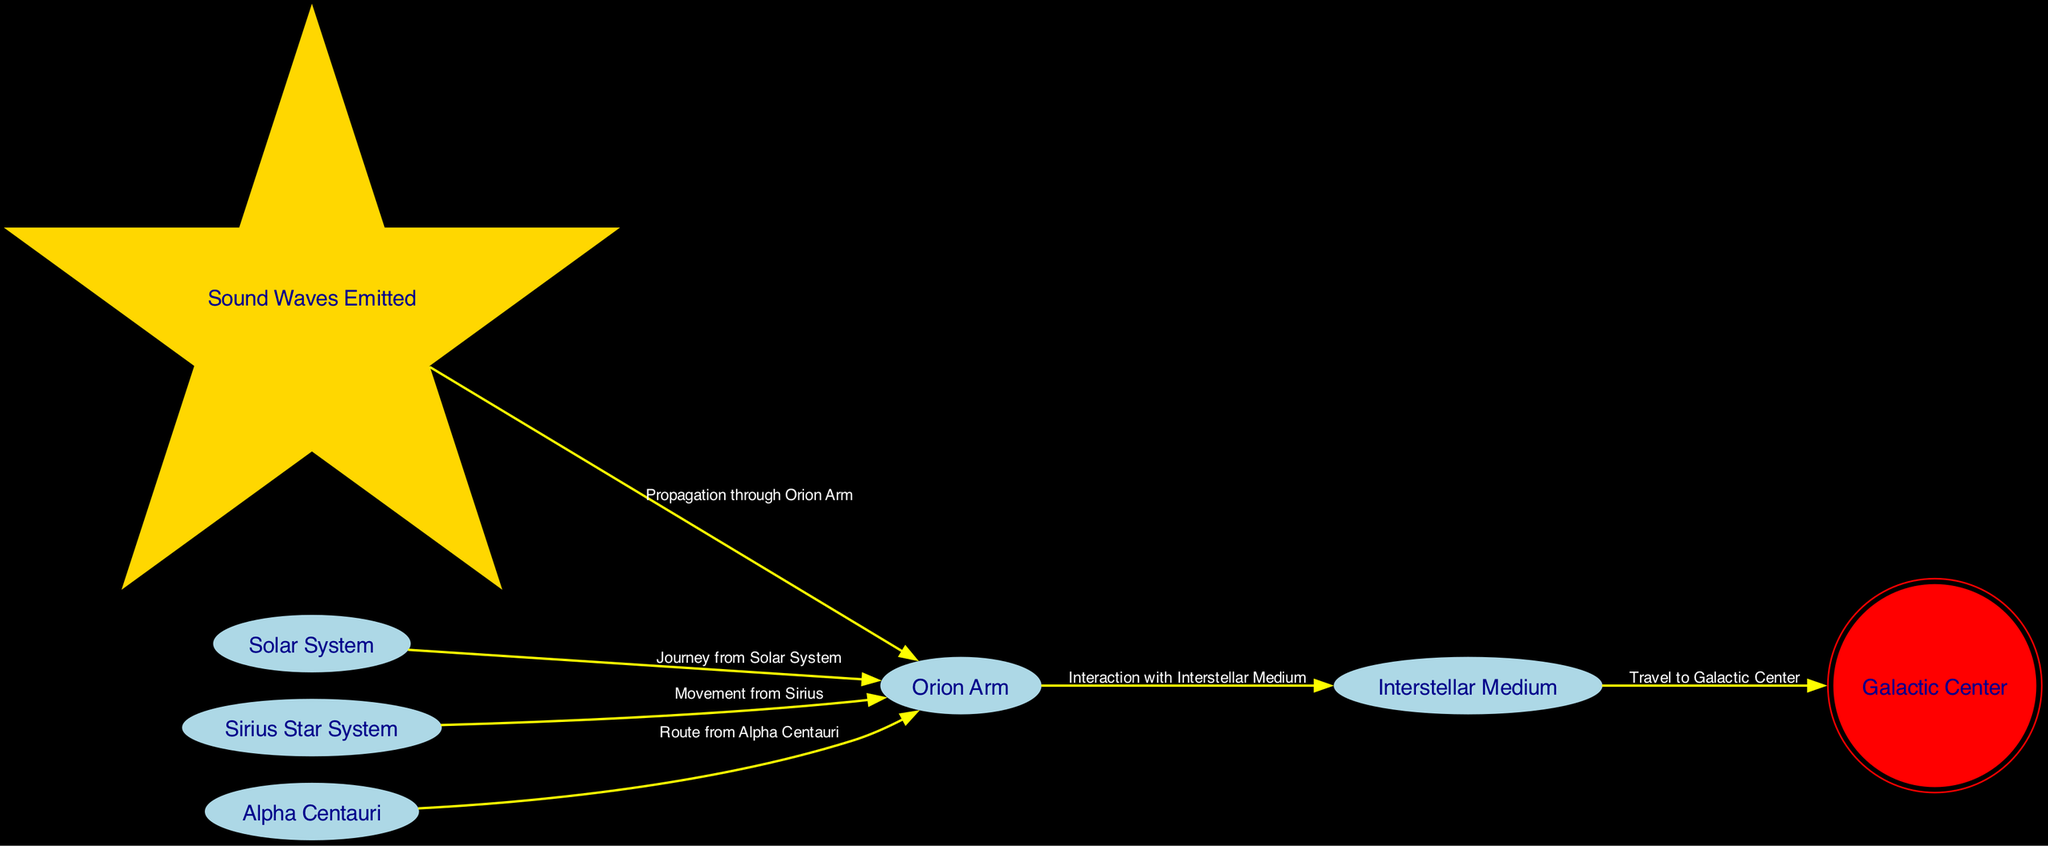What's the total number of nodes in the diagram? The diagram lists nodes that represent different locations or concepts related to sound waves in the Milky Way. Counting each entry, we find 7 distinct nodes total.
Answer: 7 What is the relationship between "Sound Waves Emitted" and "Orion Arm"? The diagram shows a direct edge labeled "Propagation through Orion Arm," indicating that sound waves emitted travel to this region. Therefore, there is a propagation relationship between these two nodes.
Answer: Propagation through Orion Arm How many edges are there in the diagram? By reviewing the connections displayed between the nodes, we can tally that there are 6 edges representing the different pathways and interactions.
Answer: 6 Which node represents the location of the Galactic Center? The node labeled "Galactic Center" is specifically identified in the diagram, making it easy to locate. The identification of the node is clear as it holds the label.
Answer: Galactic Center What are the two star systems shown in the diagram? The diagram features two star systems: "Sirius Star System" and "Alpha Centauri." These nodes are explicitly mentioned in the provided data.
Answer: Sirius Star System and Alpha Centauri From which location does sound have a journey to the "Orion Arm"? The "Solar System" node has a directed edge labeled "Journey from Solar System" leading towards the "Orion Arm," indicating that sound originates from here towards that arm.
Answer: Solar System What is the pathway from "Interstellar Medium" to "Galactic Center"? The diagram contains an edge that shows the path of sound traveling from the "Interstellar Medium" to the "Galactic Center," described as "Travel to Galactic Center." This signifies that sound interacts with the medium before reaching the center.
Answer: Travel to Galactic Center How does sound from the "Sirius Star System" reach the "Orion Arm"? According to the diagram, sound waves emanating from the "Sirius Star System" directly propagate to the "Orion Arm," indicated by the connection that identifies this pathway.
Answer: Movement from Sirius What node is connected to both "Orion Arm" and "Interstellar Medium"? The "Orion Arm" interacts with the "Interstellar Medium" through the directed edge labeled "Interaction with Interstellar Medium," indicating they are interconnected.
Answer: Interstellar Medium 